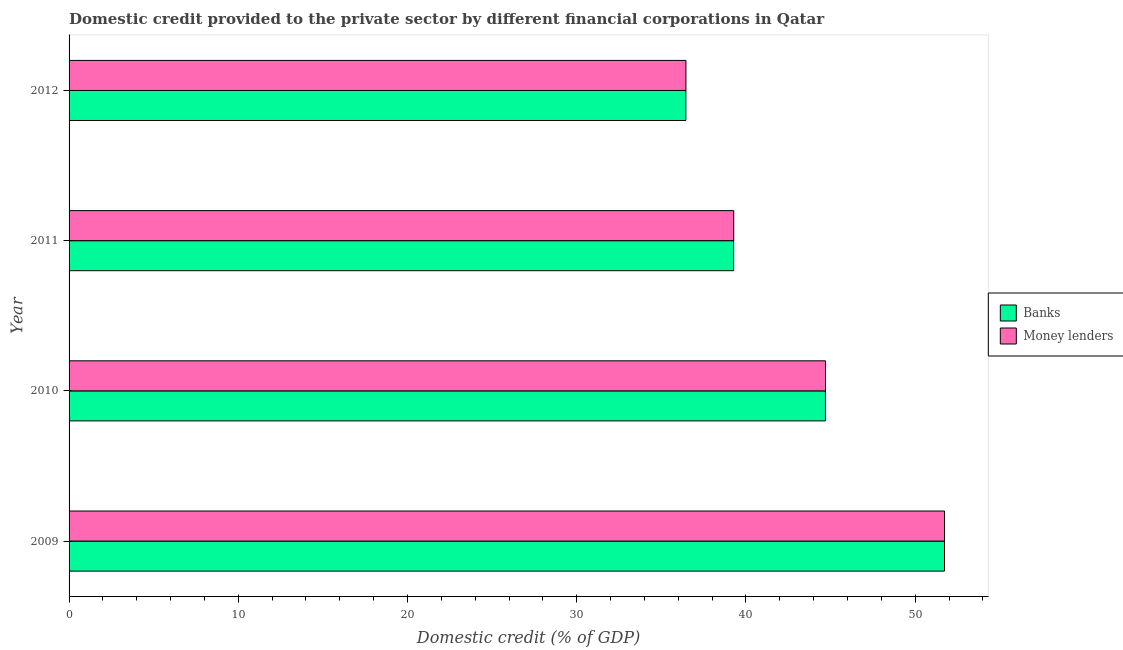Are the number of bars on each tick of the Y-axis equal?
Provide a succinct answer. Yes. How many bars are there on the 3rd tick from the top?
Keep it short and to the point. 2. What is the domestic credit provided by banks in 2011?
Ensure brevity in your answer.  39.27. Across all years, what is the maximum domestic credit provided by money lenders?
Offer a terse response. 51.74. Across all years, what is the minimum domestic credit provided by banks?
Offer a terse response. 36.45. In which year was the domestic credit provided by money lenders minimum?
Your answer should be very brief. 2012. What is the total domestic credit provided by banks in the graph?
Ensure brevity in your answer.  172.15. What is the difference between the domestic credit provided by money lenders in 2009 and that in 2010?
Keep it short and to the point. 7.03. What is the difference between the domestic credit provided by money lenders in 2012 and the domestic credit provided by banks in 2011?
Make the answer very short. -2.82. What is the average domestic credit provided by banks per year?
Your response must be concise. 43.04. In the year 2011, what is the difference between the domestic credit provided by banks and domestic credit provided by money lenders?
Offer a very short reply. -0. What is the ratio of the domestic credit provided by banks in 2010 to that in 2012?
Keep it short and to the point. 1.23. What is the difference between the highest and the second highest domestic credit provided by banks?
Keep it short and to the point. 7.04. What is the difference between the highest and the lowest domestic credit provided by banks?
Provide a succinct answer. 15.28. Is the sum of the domestic credit provided by money lenders in 2010 and 2011 greater than the maximum domestic credit provided by banks across all years?
Provide a succinct answer. Yes. What does the 1st bar from the top in 2010 represents?
Provide a short and direct response. Money lenders. What does the 1st bar from the bottom in 2010 represents?
Provide a succinct answer. Banks. What is the difference between two consecutive major ticks on the X-axis?
Provide a short and direct response. 10. Does the graph contain any zero values?
Keep it short and to the point. No. Where does the legend appear in the graph?
Provide a succinct answer. Center right. How are the legend labels stacked?
Keep it short and to the point. Vertical. What is the title of the graph?
Provide a short and direct response. Domestic credit provided to the private sector by different financial corporations in Qatar. Does "Public credit registry" appear as one of the legend labels in the graph?
Your answer should be very brief. No. What is the label or title of the X-axis?
Provide a succinct answer. Domestic credit (% of GDP). What is the label or title of the Y-axis?
Your response must be concise. Year. What is the Domestic credit (% of GDP) of Banks in 2009?
Your response must be concise. 51.73. What is the Domestic credit (% of GDP) in Money lenders in 2009?
Offer a terse response. 51.74. What is the Domestic credit (% of GDP) of Banks in 2010?
Offer a terse response. 44.7. What is the Domestic credit (% of GDP) in Money lenders in 2010?
Offer a very short reply. 44.7. What is the Domestic credit (% of GDP) of Banks in 2011?
Give a very brief answer. 39.27. What is the Domestic credit (% of GDP) of Money lenders in 2011?
Your answer should be compact. 39.28. What is the Domestic credit (% of GDP) of Banks in 2012?
Ensure brevity in your answer.  36.45. What is the Domestic credit (% of GDP) of Money lenders in 2012?
Offer a very short reply. 36.45. Across all years, what is the maximum Domestic credit (% of GDP) of Banks?
Your response must be concise. 51.73. Across all years, what is the maximum Domestic credit (% of GDP) of Money lenders?
Make the answer very short. 51.74. Across all years, what is the minimum Domestic credit (% of GDP) of Banks?
Ensure brevity in your answer.  36.45. Across all years, what is the minimum Domestic credit (% of GDP) in Money lenders?
Keep it short and to the point. 36.45. What is the total Domestic credit (% of GDP) in Banks in the graph?
Your answer should be compact. 172.15. What is the total Domestic credit (% of GDP) of Money lenders in the graph?
Give a very brief answer. 172.17. What is the difference between the Domestic credit (% of GDP) in Banks in 2009 and that in 2010?
Your answer should be compact. 7.04. What is the difference between the Domestic credit (% of GDP) of Money lenders in 2009 and that in 2010?
Your response must be concise. 7.03. What is the difference between the Domestic credit (% of GDP) of Banks in 2009 and that in 2011?
Your answer should be compact. 12.46. What is the difference between the Domestic credit (% of GDP) in Money lenders in 2009 and that in 2011?
Provide a short and direct response. 12.46. What is the difference between the Domestic credit (% of GDP) of Banks in 2009 and that in 2012?
Provide a short and direct response. 15.28. What is the difference between the Domestic credit (% of GDP) in Money lenders in 2009 and that in 2012?
Provide a short and direct response. 15.28. What is the difference between the Domestic credit (% of GDP) of Banks in 2010 and that in 2011?
Offer a very short reply. 5.42. What is the difference between the Domestic credit (% of GDP) in Money lenders in 2010 and that in 2011?
Your answer should be very brief. 5.42. What is the difference between the Domestic credit (% of GDP) in Banks in 2010 and that in 2012?
Your response must be concise. 8.25. What is the difference between the Domestic credit (% of GDP) of Money lenders in 2010 and that in 2012?
Offer a terse response. 8.25. What is the difference between the Domestic credit (% of GDP) in Banks in 2011 and that in 2012?
Your response must be concise. 2.82. What is the difference between the Domestic credit (% of GDP) in Money lenders in 2011 and that in 2012?
Offer a terse response. 2.82. What is the difference between the Domestic credit (% of GDP) in Banks in 2009 and the Domestic credit (% of GDP) in Money lenders in 2010?
Offer a terse response. 7.03. What is the difference between the Domestic credit (% of GDP) in Banks in 2009 and the Domestic credit (% of GDP) in Money lenders in 2011?
Make the answer very short. 12.46. What is the difference between the Domestic credit (% of GDP) in Banks in 2009 and the Domestic credit (% of GDP) in Money lenders in 2012?
Provide a succinct answer. 15.28. What is the difference between the Domestic credit (% of GDP) in Banks in 2010 and the Domestic credit (% of GDP) in Money lenders in 2011?
Provide a short and direct response. 5.42. What is the difference between the Domestic credit (% of GDP) of Banks in 2010 and the Domestic credit (% of GDP) of Money lenders in 2012?
Ensure brevity in your answer.  8.24. What is the difference between the Domestic credit (% of GDP) in Banks in 2011 and the Domestic credit (% of GDP) in Money lenders in 2012?
Offer a terse response. 2.82. What is the average Domestic credit (% of GDP) in Banks per year?
Provide a short and direct response. 43.04. What is the average Domestic credit (% of GDP) of Money lenders per year?
Offer a terse response. 43.04. In the year 2009, what is the difference between the Domestic credit (% of GDP) of Banks and Domestic credit (% of GDP) of Money lenders?
Your answer should be very brief. -0. In the year 2010, what is the difference between the Domestic credit (% of GDP) of Banks and Domestic credit (% of GDP) of Money lenders?
Keep it short and to the point. -0.01. In the year 2011, what is the difference between the Domestic credit (% of GDP) in Banks and Domestic credit (% of GDP) in Money lenders?
Provide a succinct answer. -0. In the year 2012, what is the difference between the Domestic credit (% of GDP) in Banks and Domestic credit (% of GDP) in Money lenders?
Offer a very short reply. -0. What is the ratio of the Domestic credit (% of GDP) of Banks in 2009 to that in 2010?
Make the answer very short. 1.16. What is the ratio of the Domestic credit (% of GDP) in Money lenders in 2009 to that in 2010?
Ensure brevity in your answer.  1.16. What is the ratio of the Domestic credit (% of GDP) in Banks in 2009 to that in 2011?
Make the answer very short. 1.32. What is the ratio of the Domestic credit (% of GDP) of Money lenders in 2009 to that in 2011?
Provide a short and direct response. 1.32. What is the ratio of the Domestic credit (% of GDP) in Banks in 2009 to that in 2012?
Your answer should be compact. 1.42. What is the ratio of the Domestic credit (% of GDP) in Money lenders in 2009 to that in 2012?
Ensure brevity in your answer.  1.42. What is the ratio of the Domestic credit (% of GDP) of Banks in 2010 to that in 2011?
Ensure brevity in your answer.  1.14. What is the ratio of the Domestic credit (% of GDP) of Money lenders in 2010 to that in 2011?
Offer a very short reply. 1.14. What is the ratio of the Domestic credit (% of GDP) of Banks in 2010 to that in 2012?
Keep it short and to the point. 1.23. What is the ratio of the Domestic credit (% of GDP) in Money lenders in 2010 to that in 2012?
Offer a very short reply. 1.23. What is the ratio of the Domestic credit (% of GDP) in Banks in 2011 to that in 2012?
Provide a succinct answer. 1.08. What is the ratio of the Domestic credit (% of GDP) of Money lenders in 2011 to that in 2012?
Offer a very short reply. 1.08. What is the difference between the highest and the second highest Domestic credit (% of GDP) in Banks?
Offer a very short reply. 7.04. What is the difference between the highest and the second highest Domestic credit (% of GDP) in Money lenders?
Your answer should be compact. 7.03. What is the difference between the highest and the lowest Domestic credit (% of GDP) in Banks?
Make the answer very short. 15.28. What is the difference between the highest and the lowest Domestic credit (% of GDP) in Money lenders?
Give a very brief answer. 15.28. 